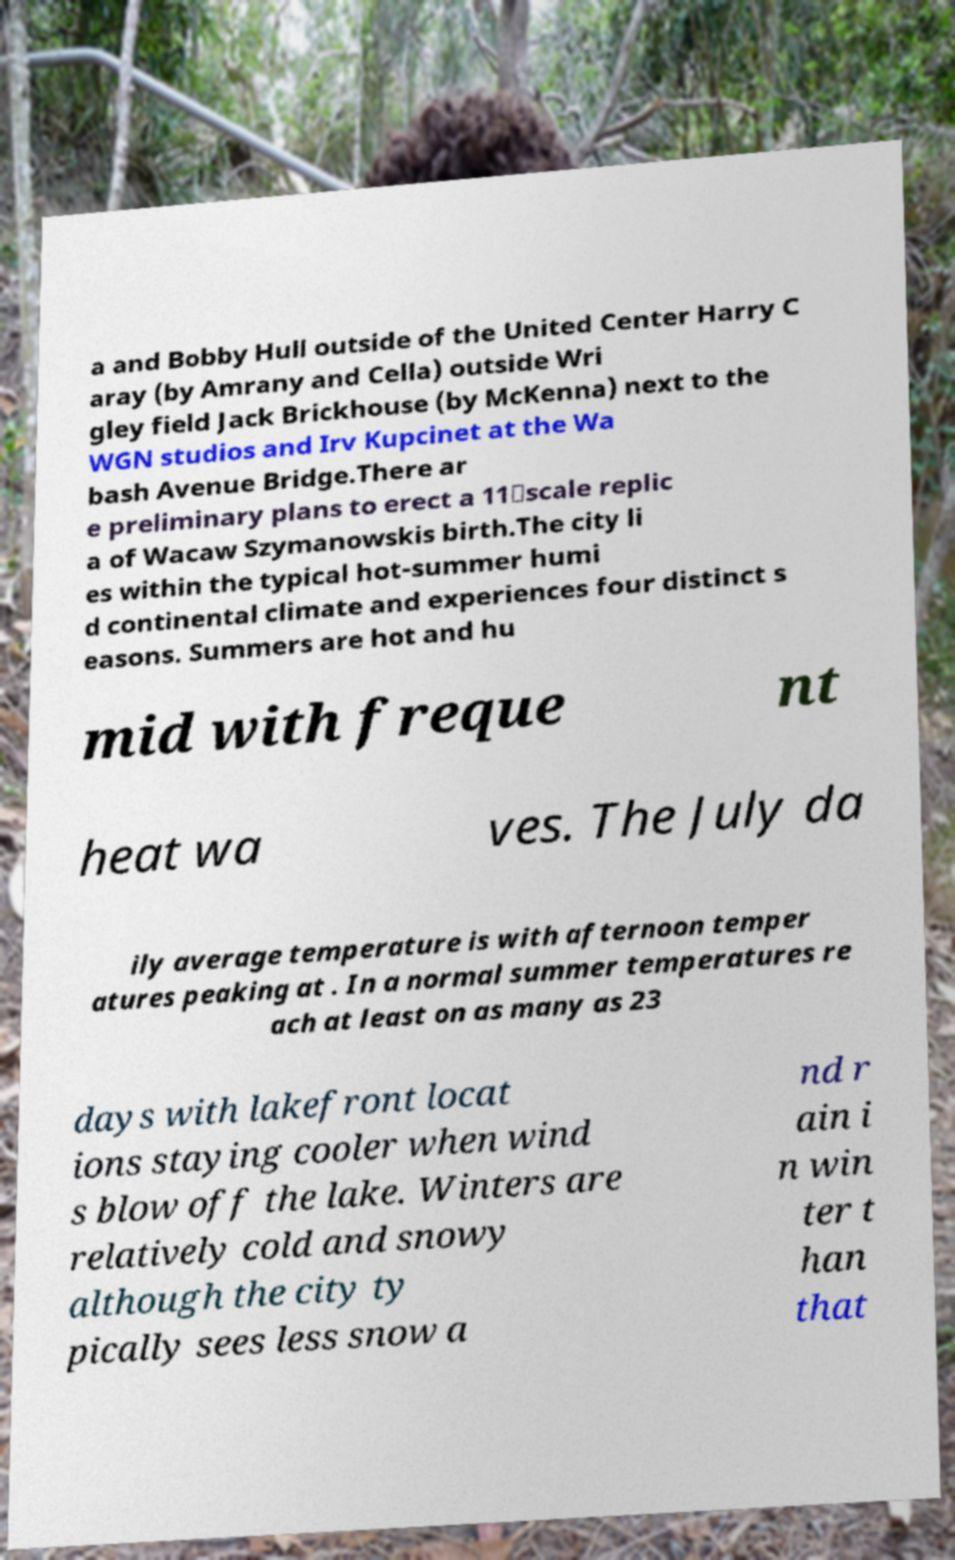For documentation purposes, I need the text within this image transcribed. Could you provide that? a and Bobby Hull outside of the United Center Harry C aray (by Amrany and Cella) outside Wri gley field Jack Brickhouse (by McKenna) next to the WGN studios and Irv Kupcinet at the Wa bash Avenue Bridge.There ar e preliminary plans to erect a 11‑scale replic a of Wacaw Szymanowskis birth.The city li es within the typical hot-summer humi d continental climate and experiences four distinct s easons. Summers are hot and hu mid with freque nt heat wa ves. The July da ily average temperature is with afternoon temper atures peaking at . In a normal summer temperatures re ach at least on as many as 23 days with lakefront locat ions staying cooler when wind s blow off the lake. Winters are relatively cold and snowy although the city ty pically sees less snow a nd r ain i n win ter t han that 